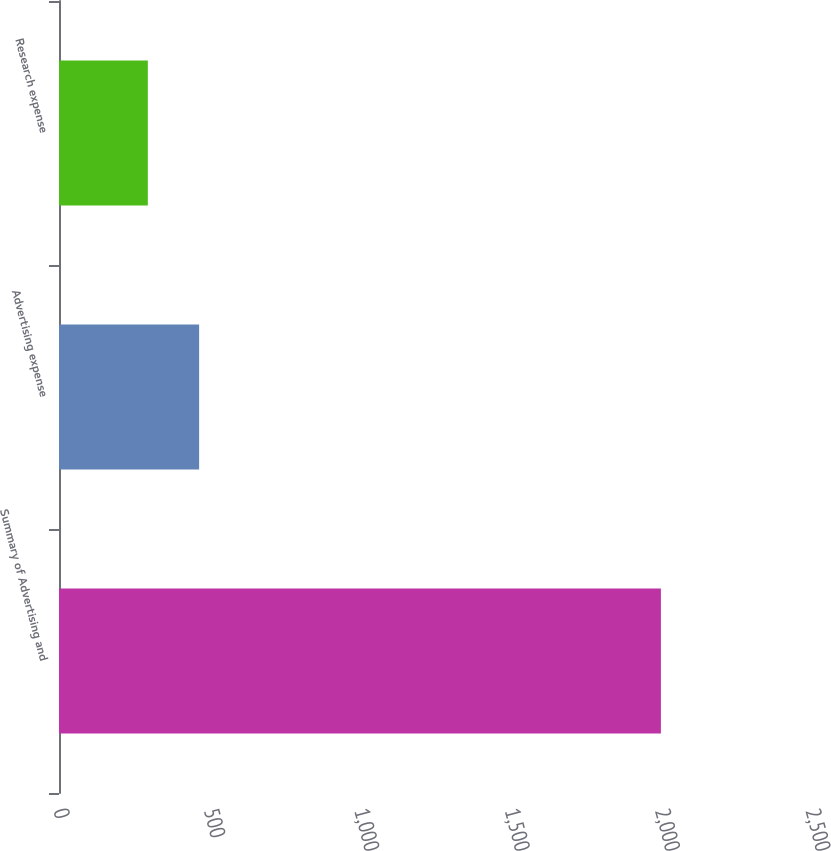Convert chart to OTSL. <chart><loc_0><loc_0><loc_500><loc_500><bar_chart><fcel>Summary of Advertising and<fcel>Advertising expense<fcel>Research expense<nl><fcel>2001<fcel>465.87<fcel>295.3<nl></chart> 